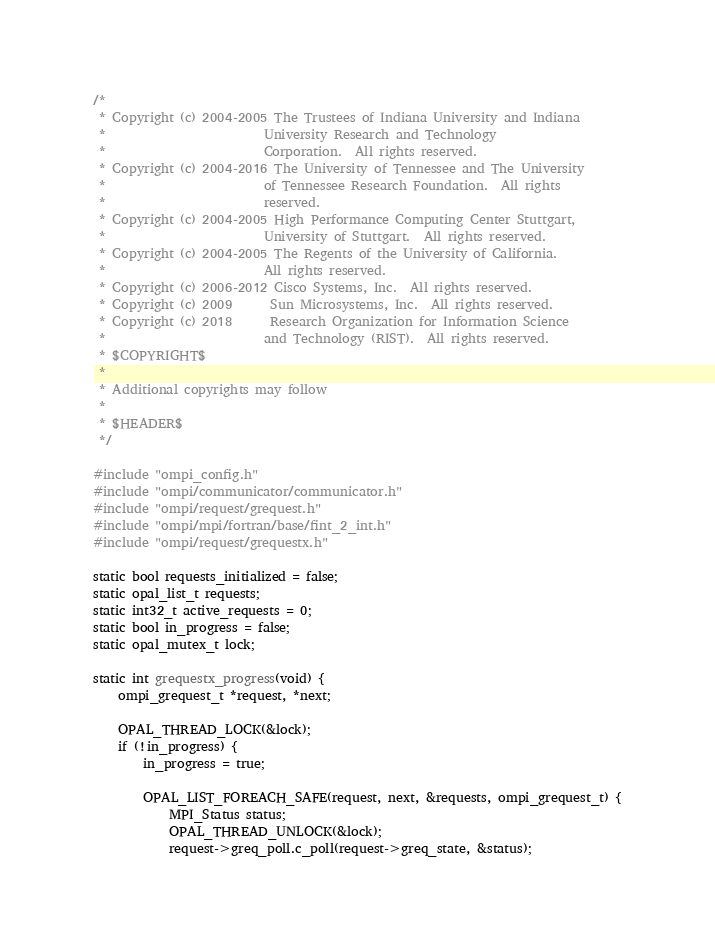<code> <loc_0><loc_0><loc_500><loc_500><_C_>/*
 * Copyright (c) 2004-2005 The Trustees of Indiana University and Indiana
 *                         University Research and Technology
 *                         Corporation.  All rights reserved.
 * Copyright (c) 2004-2016 The University of Tennessee and The University
 *                         of Tennessee Research Foundation.  All rights
 *                         reserved.
 * Copyright (c) 2004-2005 High Performance Computing Center Stuttgart,
 *                         University of Stuttgart.  All rights reserved.
 * Copyright (c) 2004-2005 The Regents of the University of California.
 *                         All rights reserved.
 * Copyright (c) 2006-2012 Cisco Systems, Inc.  All rights reserved.
 * Copyright (c) 2009      Sun Microsystems, Inc.  All rights reserved.
 * Copyright (c) 2018      Research Organization for Information Science
 *                         and Technology (RIST).  All rights reserved.
 * $COPYRIGHT$
 *
 * Additional copyrights may follow
 *
 * $HEADER$
 */

#include "ompi_config.h"
#include "ompi/communicator/communicator.h"
#include "ompi/request/grequest.h"
#include "ompi/mpi/fortran/base/fint_2_int.h"
#include "ompi/request/grequestx.h"

static bool requests_initialized = false;
static opal_list_t requests;
static int32_t active_requests = 0;
static bool in_progress = false;
static opal_mutex_t lock;

static int grequestx_progress(void) {
    ompi_grequest_t *request, *next;

    OPAL_THREAD_LOCK(&lock);
    if (!in_progress) {
        in_progress = true;

        OPAL_LIST_FOREACH_SAFE(request, next, &requests, ompi_grequest_t) {
            MPI_Status status;
            OPAL_THREAD_UNLOCK(&lock);
            request->greq_poll.c_poll(request->greq_state, &status);</code> 